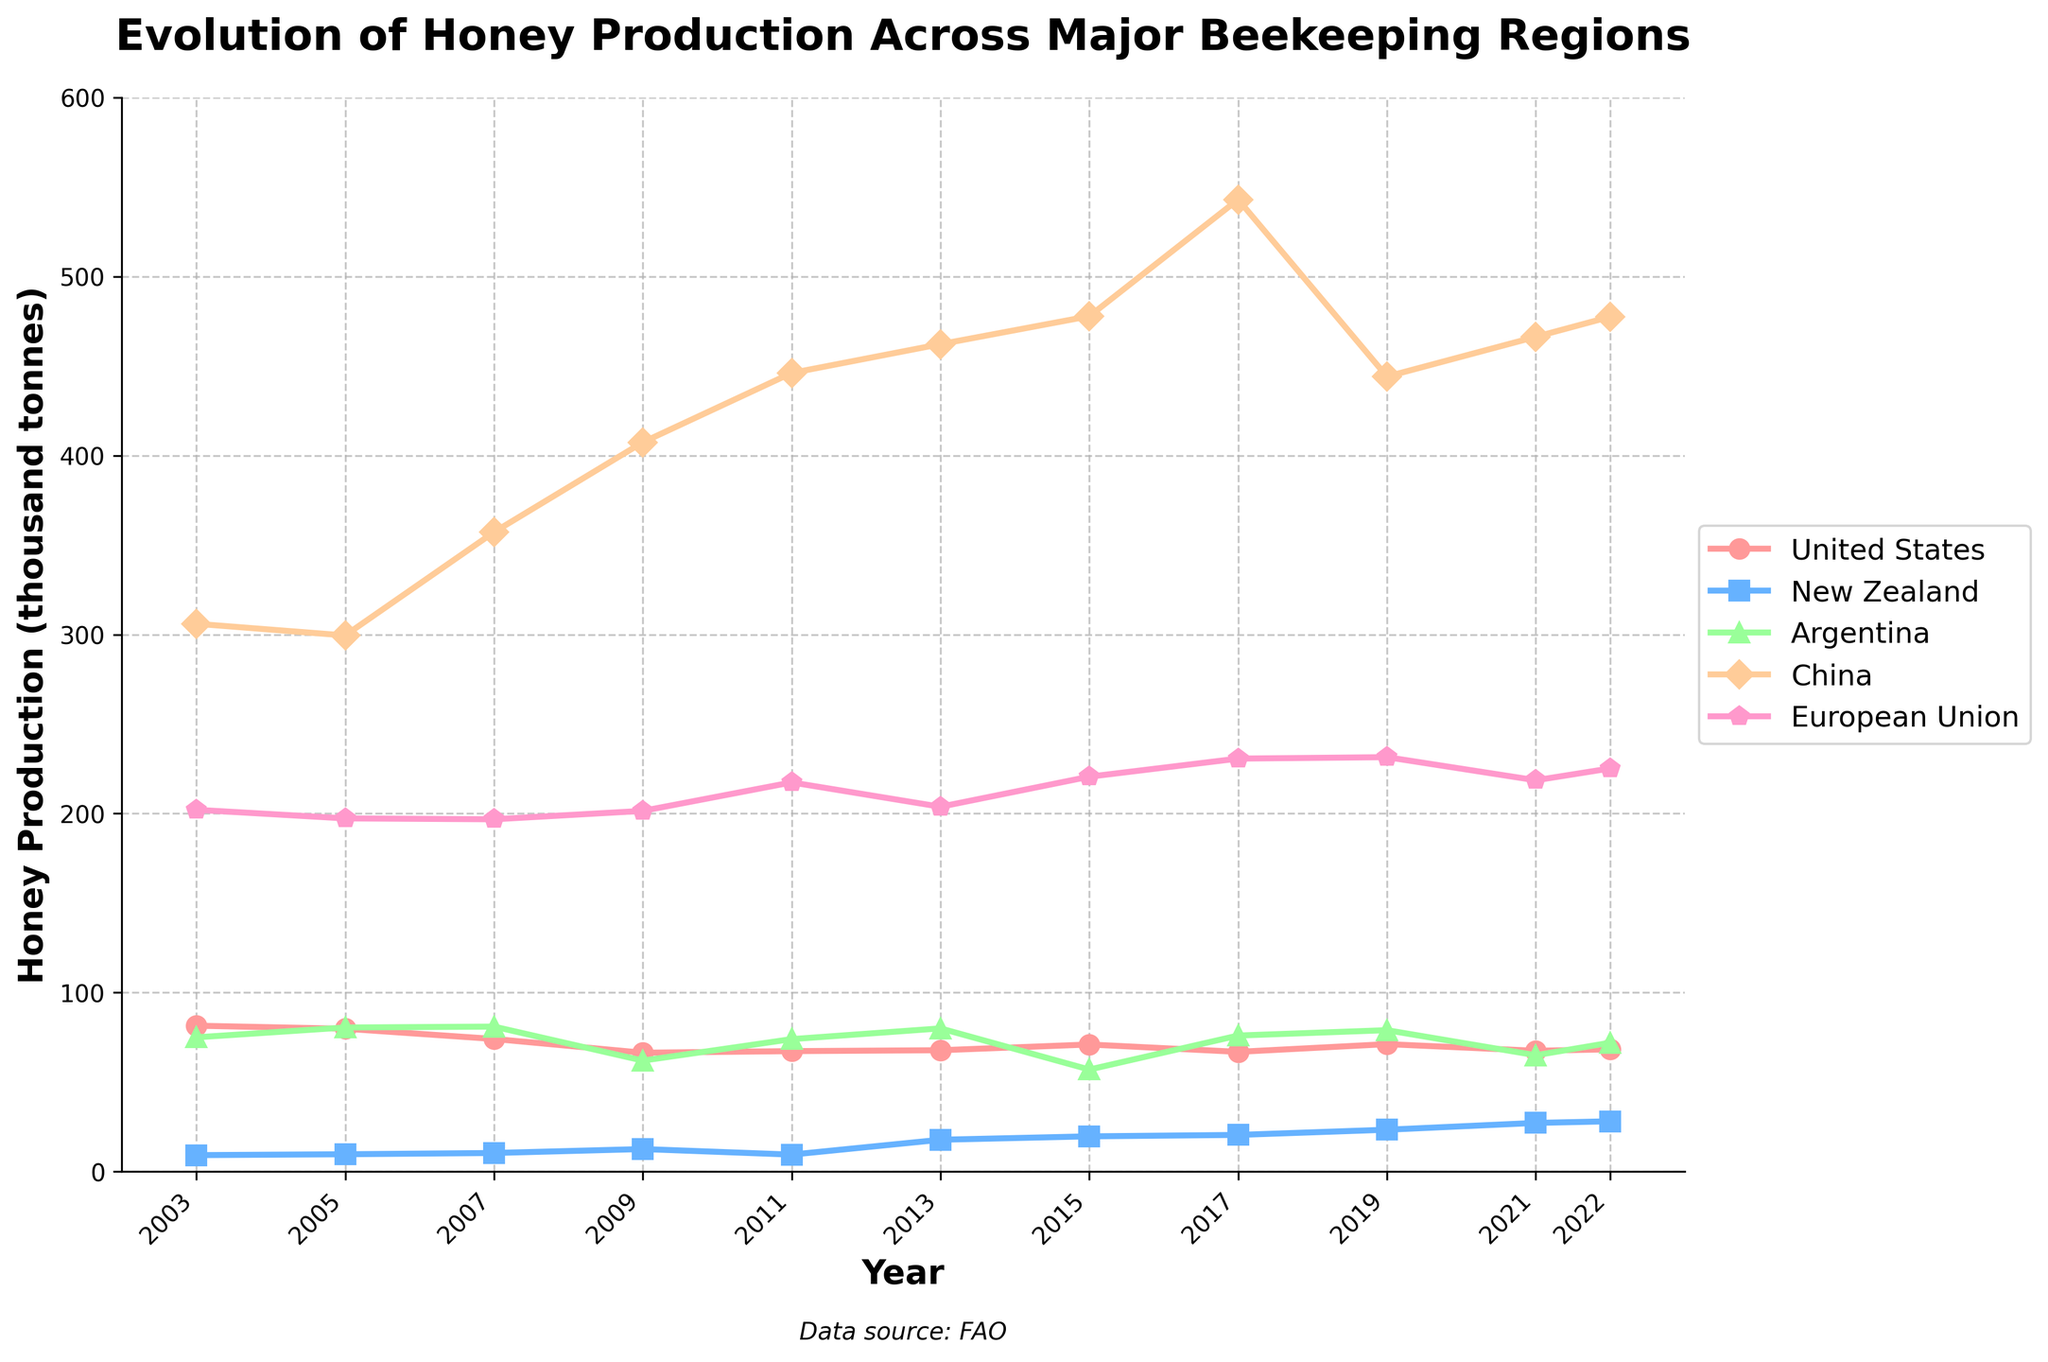What year did China reach its highest honey production? Looking at the line for China, we see that the peak is in the year 2017.
Answer: 2017 Which country had the lowest honey production in 2003? Observing the points on the chart for the year 2003, New Zealand has the lowest value at 9.2 thousand tonnes.
Answer: New Zealand Between which years did the European Union show the largest increase in honey production? By comparing the slopes of the line for the European Union, the largest increase happened between 2009 and 2011.
Answer: 2009 to 2011 How many thousand tonnes of honey did the United States produce in 2015? Locating the data point for the United States in 2015, the production is 71.0 thousand tonnes.
Answer: 71.0 Which years did Argentina have a honey production above 70 thousand tonnes? Looking at the chart for Argentina, the years 2003, 2005, 2007, 2011, 2013, 2017, and 2019 had production above 70 thousand tonnes.
Answer: 2003, 2005, 2007, 2011, 2013, 2017, 2019 Compare the honey production of New Zealand and Argentina in 2022. Which country produced more? Checking the endpoints of the lines for New Zealand and Argentina in 2022, New Zealand produced 28.1 thousand tonnes while Argentina produced 72.0 thousand tonnes. Thus, Argentina produced more.
Answer: Argentina What's the difference in honey production between the European Union and the United States in 2021? From the values in 2021, European Union's production is 218.6 thousand tonnes and the United States' production is 67.5 thousand tonnes. The difference is 218.6 - 67.5 = 151.1 thousand tonnes.
Answer: 151.1 In how many years did China produce over 400 thousand tonnes of honey? Observing the chart for China, it produced over 400 thousand tonnes of honey in 2009, 2011, 2013, 2015, 2017, 2021, and 2022.
Answer: 7 What was the trend in New Zealand's honey production between 2003 and 2022? The line representing New Zealand's honey production shows a general increasing trend from 9.2 thousand tonnes in 2003 to 28.1 thousand tonnes in 2022, despite some fluctuations.
Answer: Increasing 